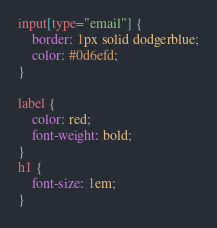<code> <loc_0><loc_0><loc_500><loc_500><_CSS_>input[type="email"] {
    border: 1px solid dodgerblue;
    color: #0d6efd;
}

label {
    color: red;
    font-weight: bold;
}
h1 {
    font-size: 1em;
}</code> 